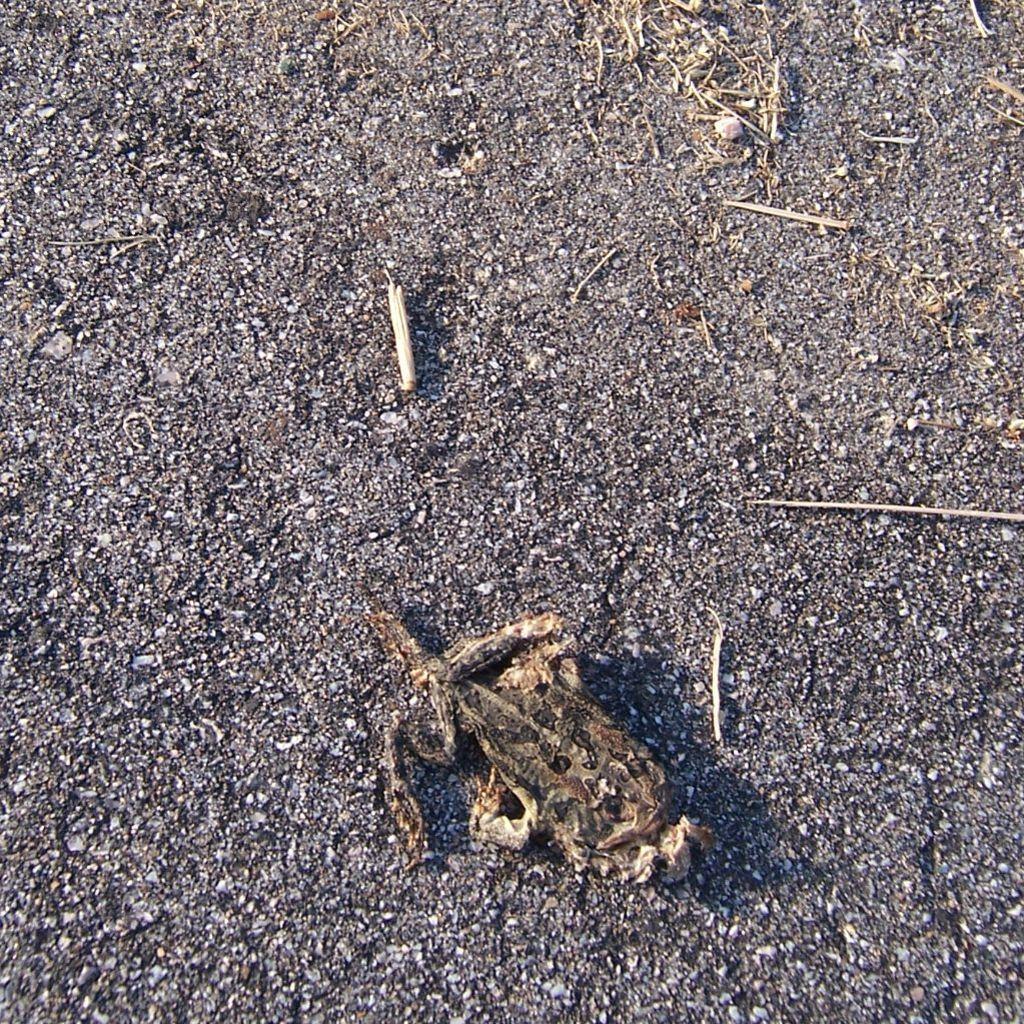How would you summarize this image in a sentence or two? In this image we can see some wooden pieces on the land. 